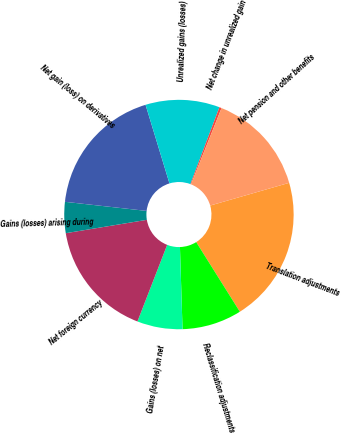Convert chart to OTSL. <chart><loc_0><loc_0><loc_500><loc_500><pie_chart><fcel>Translation adjustments<fcel>Reclassification adjustments<fcel>Gains (losses) on net<fcel>Net foreign currency<fcel>Gains (losses) arising during<fcel>Net gain (loss) on derivatives<fcel>Unrealized gains (losses)<fcel>Net change in unrealized gain<fcel>Net pension and other benefits<nl><fcel>20.55%<fcel>8.41%<fcel>6.39%<fcel>16.51%<fcel>4.37%<fcel>18.53%<fcel>10.44%<fcel>0.32%<fcel>14.48%<nl></chart> 